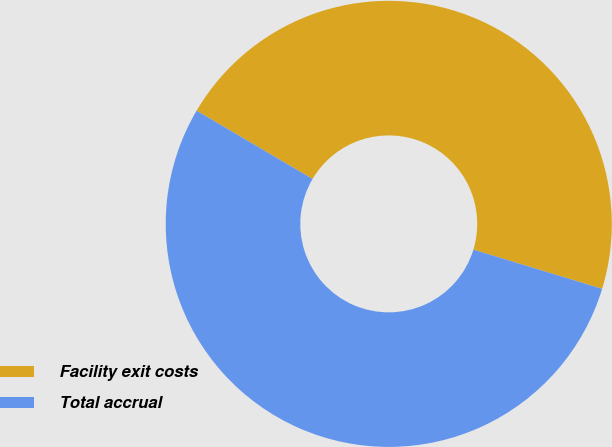<chart> <loc_0><loc_0><loc_500><loc_500><pie_chart><fcel>Facility exit costs<fcel>Total accrual<nl><fcel>46.23%<fcel>53.77%<nl></chart> 